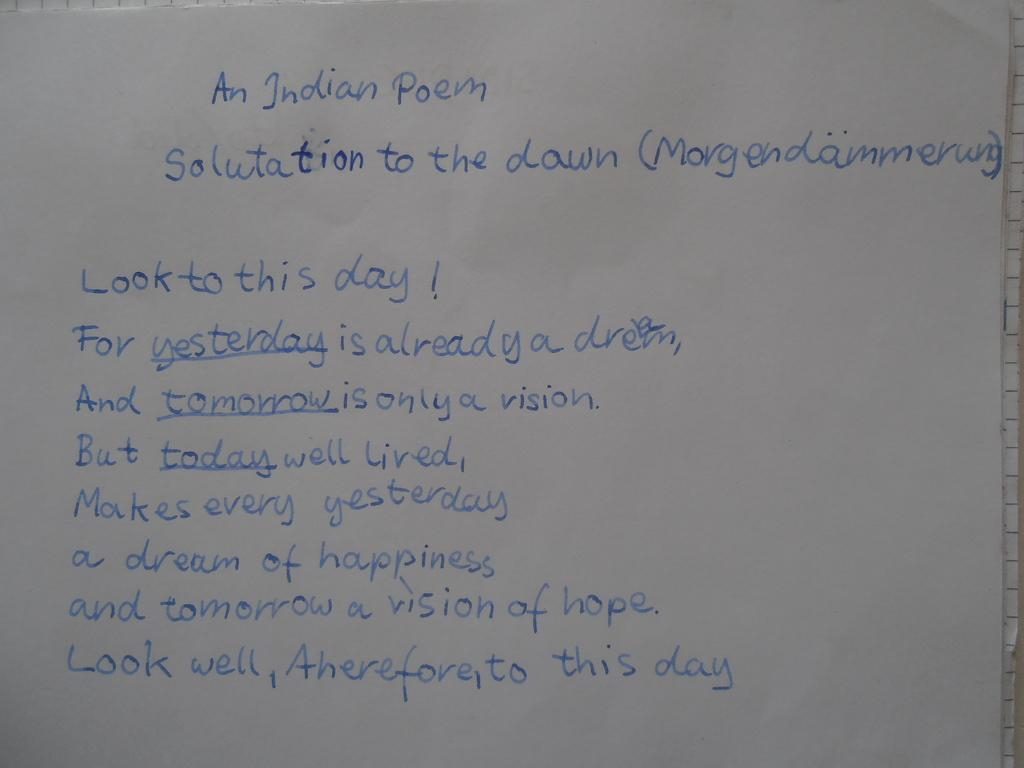Provide a one-sentence caption for the provided image. An Indian poem that is titled "Salutation To The Down". 